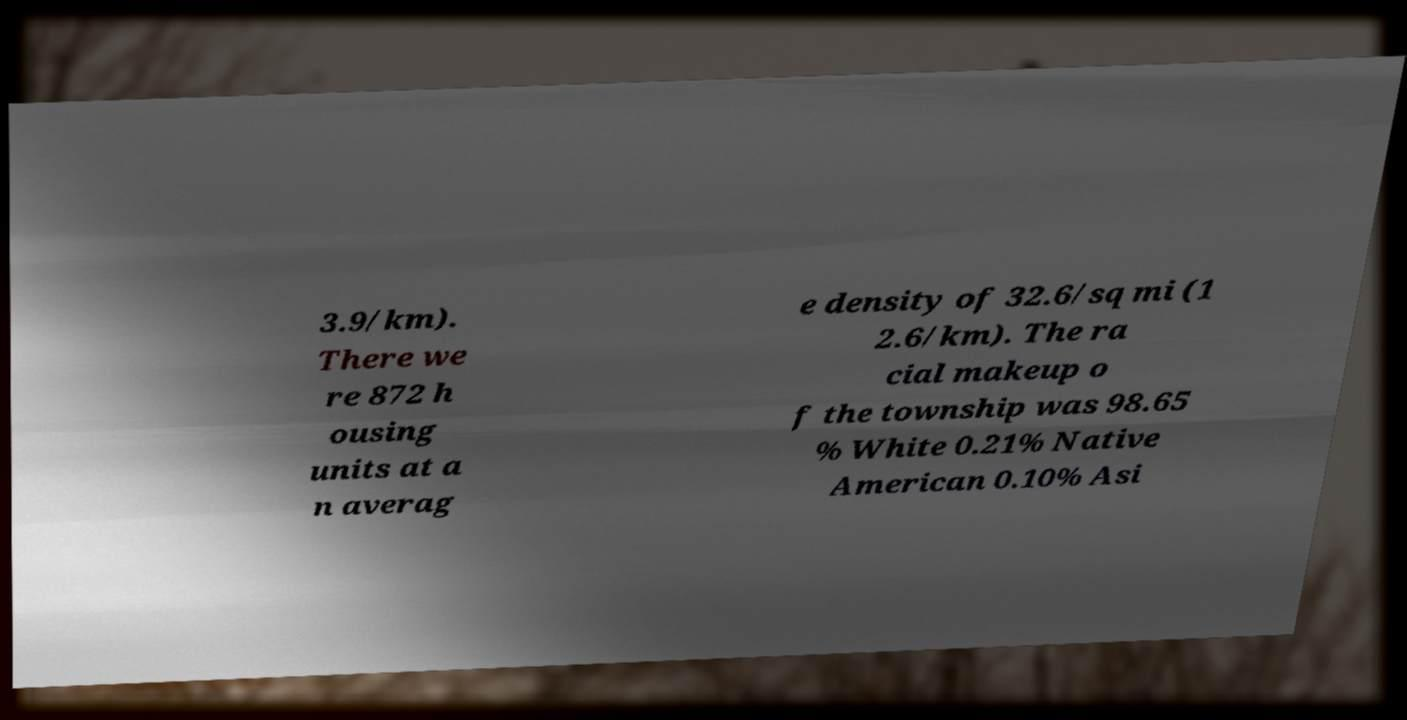Can you read and provide the text displayed in the image?This photo seems to have some interesting text. Can you extract and type it out for me? 3.9/km). There we re 872 h ousing units at a n averag e density of 32.6/sq mi (1 2.6/km). The ra cial makeup o f the township was 98.65 % White 0.21% Native American 0.10% Asi 